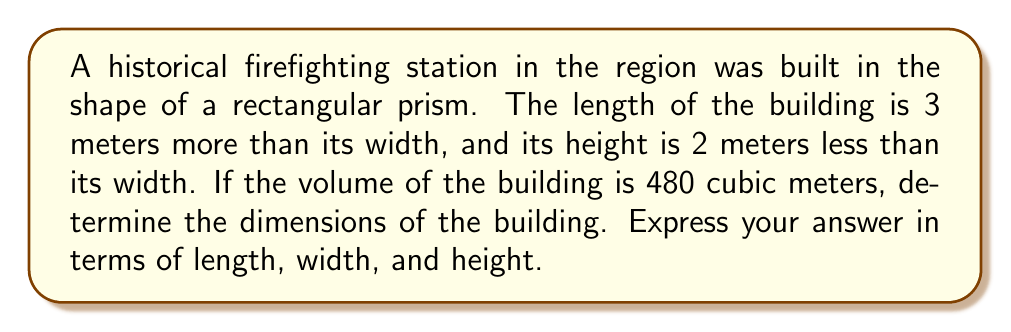Can you answer this question? Let's approach this step-by-step using a system of equations:

1) Let $w$ = width, $l$ = length, and $h$ = height.

2) Given information:
   $l = w + 3$
   $h = w - 2$
   Volume $= l \times w \times h = 480$

3) Substituting the expressions for $l$ and $h$ into the volume equation:
   $$(w + 3) \times w \times (w - 2) = 480$$

4) Expanding the equation:
   $$w^3 + w^2 - 2w^2 - 6w + 3w^2 - 6 = 480$$
   $$w^3 + 2w^2 - 3w - 486 = 0$$

5) This is a cubic equation. We can solve it by factoring or using the cubic formula. By factoring:
   $$(w - 6)(w^2 + 8w + 81) = 0$$

6) Solving this equation:
   $w = 6$ (as the other factor doesn't have real roots)

7) Now we can find $l$ and $h$:
   $l = w + 3 = 6 + 3 = 9$
   $h = w - 2 = 6 - 2 = 4$

8) Verifying the solution:
   Volume $= 9 \times 6 \times 4 = 216$ cubic meters

Therefore, the dimensions of the building are:
Length = 9 meters
Width = 6 meters
Height = 4 meters
Answer: $l = 9$ m, $w = 6$ m, $h = 4$ m 